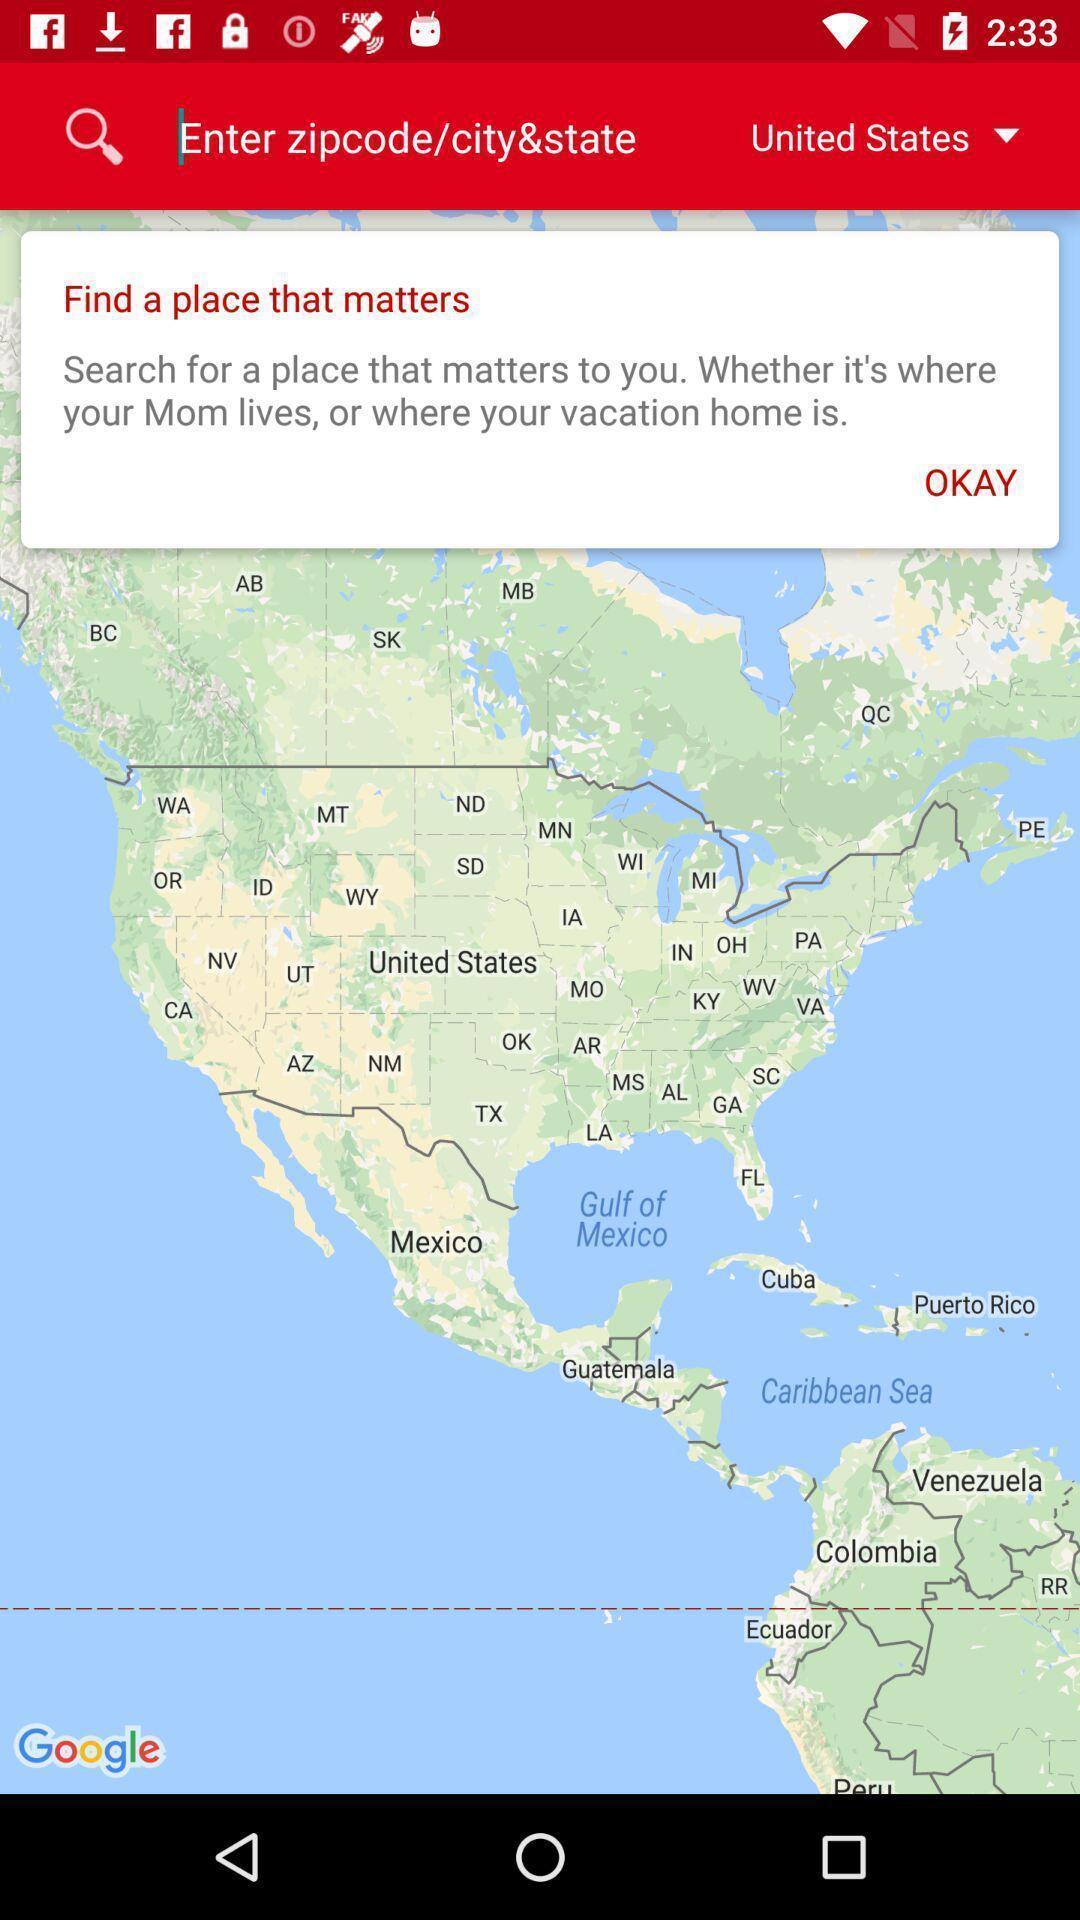What can you discern from this picture? Page that displaying a map to enter code. 